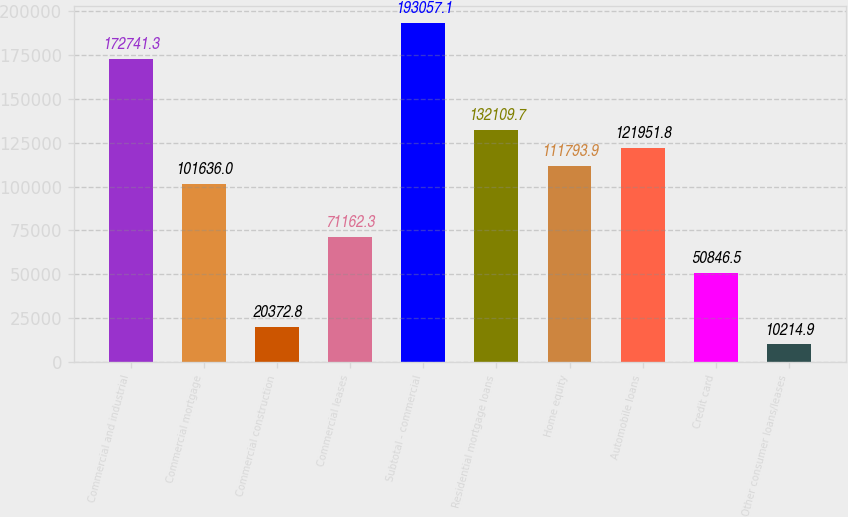<chart> <loc_0><loc_0><loc_500><loc_500><bar_chart><fcel>Commercial and industrial<fcel>Commercial mortgage<fcel>Commercial construction<fcel>Commercial leases<fcel>Subtotal - commercial<fcel>Residential mortgage loans<fcel>Home equity<fcel>Automobile loans<fcel>Credit card<fcel>Other consumer loans/leases<nl><fcel>172741<fcel>101636<fcel>20372.8<fcel>71162.3<fcel>193057<fcel>132110<fcel>111794<fcel>121952<fcel>50846.5<fcel>10214.9<nl></chart> 